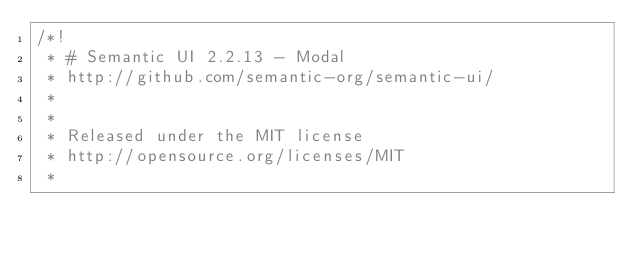Convert code to text. <code><loc_0><loc_0><loc_500><loc_500><_CSS_>/*!
 * # Semantic UI 2.2.13 - Modal
 * http://github.com/semantic-org/semantic-ui/
 *
 *
 * Released under the MIT license
 * http://opensource.org/licenses/MIT
 *</code> 